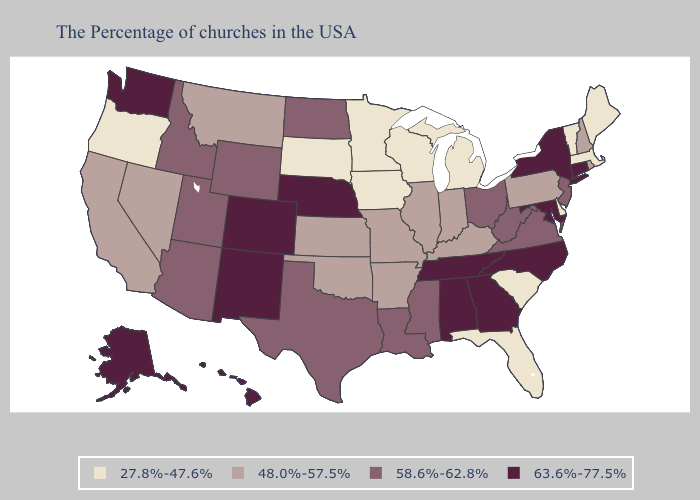Name the states that have a value in the range 63.6%-77.5%?
Quick response, please. Connecticut, New York, Maryland, North Carolina, Georgia, Alabama, Tennessee, Nebraska, Colorado, New Mexico, Washington, Alaska, Hawaii. Name the states that have a value in the range 58.6%-62.8%?
Quick response, please. New Jersey, Virginia, West Virginia, Ohio, Mississippi, Louisiana, Texas, North Dakota, Wyoming, Utah, Arizona, Idaho. What is the lowest value in the West?
Give a very brief answer. 27.8%-47.6%. Among the states that border Washington , does Idaho have the highest value?
Answer briefly. Yes. Does the first symbol in the legend represent the smallest category?
Keep it brief. Yes. What is the value of Texas?
Write a very short answer. 58.6%-62.8%. Name the states that have a value in the range 27.8%-47.6%?
Write a very short answer. Maine, Massachusetts, Vermont, Delaware, South Carolina, Florida, Michigan, Wisconsin, Minnesota, Iowa, South Dakota, Oregon. What is the value of Minnesota?
Keep it brief. 27.8%-47.6%. Does Arizona have the lowest value in the West?
Short answer required. No. Which states have the highest value in the USA?
Keep it brief. Connecticut, New York, Maryland, North Carolina, Georgia, Alabama, Tennessee, Nebraska, Colorado, New Mexico, Washington, Alaska, Hawaii. Does the map have missing data?
Quick response, please. No. Name the states that have a value in the range 63.6%-77.5%?
Concise answer only. Connecticut, New York, Maryland, North Carolina, Georgia, Alabama, Tennessee, Nebraska, Colorado, New Mexico, Washington, Alaska, Hawaii. What is the value of Maine?
Quick response, please. 27.8%-47.6%. Does the map have missing data?
Give a very brief answer. No. Does North Carolina have the highest value in the South?
Answer briefly. Yes. 